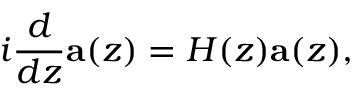Convert formula to latex. <formula><loc_0><loc_0><loc_500><loc_500>i \frac { d } { d z } a ( z ) = H ( z ) a ( z ) ,</formula> 